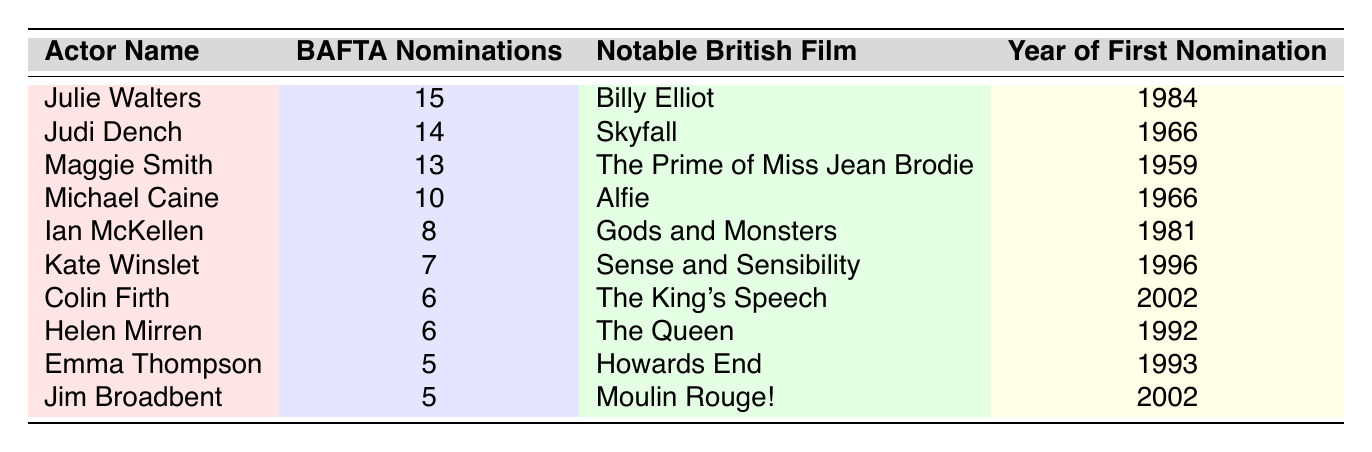What is the highest number of BAFTA nominations among the actors listed? The table shows the number of BAFTA nominations for each actor, and the highest value is 15 for Julie Walters.
Answer: 15 Which actor is associated with the notable film "Skyfall"? "Skyfall" is mentioned as the notable British film for Judi Dench in the table.
Answer: Judi Dench How many actors have received 6 or more BAFTA nominations? By looking at the table, there are five actors with 6 or more nominations: Julie Walters, Judi Dench, Maggie Smith, Michael Caine, and Ian McKellen.
Answer: 5 What is the difference in BAFTA nominations between Julie Walters and Judi Dench? Julie Walters has 15 nominations and Judi Dench has 14 nominations. The difference is 15 - 14 = 1.
Answer: 1 Which actor had their first BAFTA nomination in the year 1966? According to the table, both Michael Caine and Judi Dench had their first nominations in 1966.
Answer: Michael Caine and Judi Dench If we look at the average number of BAFTA nominations for actors with more than 5 nominations, what would it be? The actors with more than 5 nominations are: Julie Walters (15), Judi Dench (14), Maggie Smith (13), Michael Caine (10), Ian McKellen (8), Kate Winslet (7), Colin Firth (6), and Helen Mirren (6). Adding these gives 15 + 14 + 13 + 10 + 8 + 7 + 6 + 6 = 79. There are 8 actors, so the average is 79/8 = 9.875.
Answer: 9.875 Is it true that Kate Winslet has more BAFTA nominations than Jim Broadbent? The table shows Kate Winslet has 7 nominations and Jim Broadbent has 5 nominations; therefore, it is true.
Answer: Yes Which actor has the least number of BAFTA nominations among those listed? The actor with the least number of nominations is Emma Thompson and Jim Broadbent, both with 5 nominations.
Answer: Emma Thompson and Jim Broadbent Which notable British film is associated with Ian McKellen? According to the table, Ian McKellen is associated with "Gods and Monsters."
Answer: Gods and Monsters How many BAFTA nominations did Helen Mirren receive compared to Michael Caine? Helen Mirren has 6 nominations, while Michael Caine has 10. Thus, Michael Caine has 10 - 6 = 4 more nominations than Helen Mirren.
Answer: 4 Did any actors receive their first BAFTA nomination in the 1980s? The table indicates Ian McKellen had his first nomination in 1981, which confirms that at least one actor received their first nomination in the 1980s.
Answer: Yes 